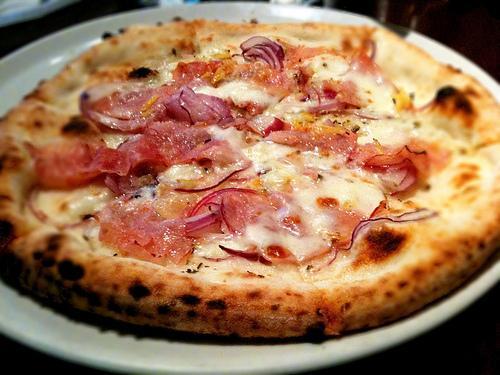How many pizzas?
Give a very brief answer. 1. 